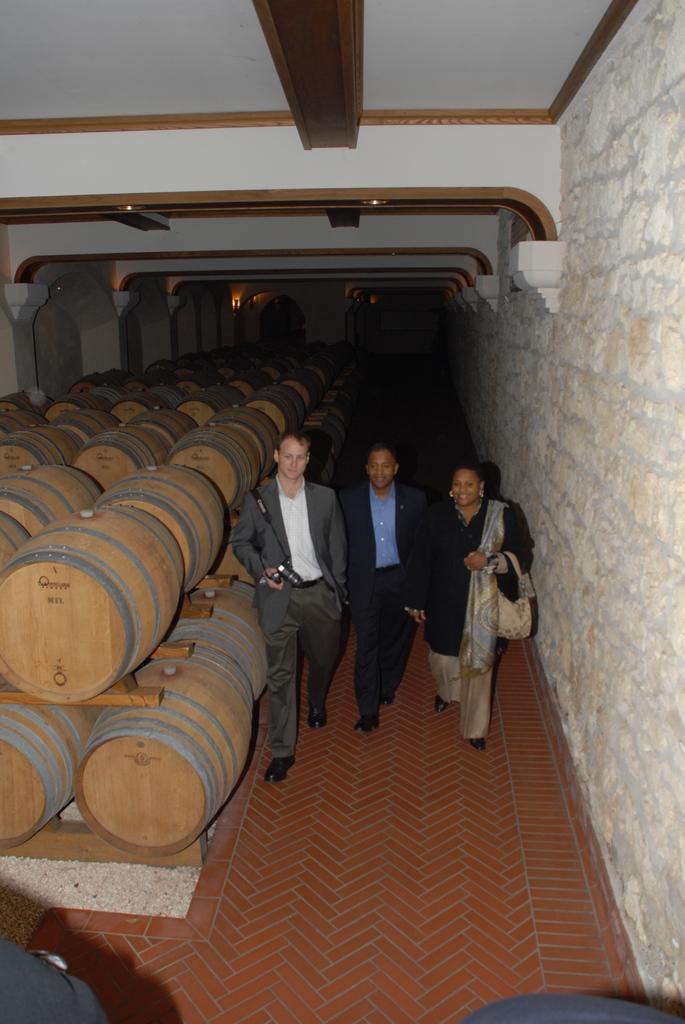Can you describe this image briefly? In this picture we can see a group of barrels, three people walking on the ground and some objects and in the background we can see the wall, ceiling and the lights. 